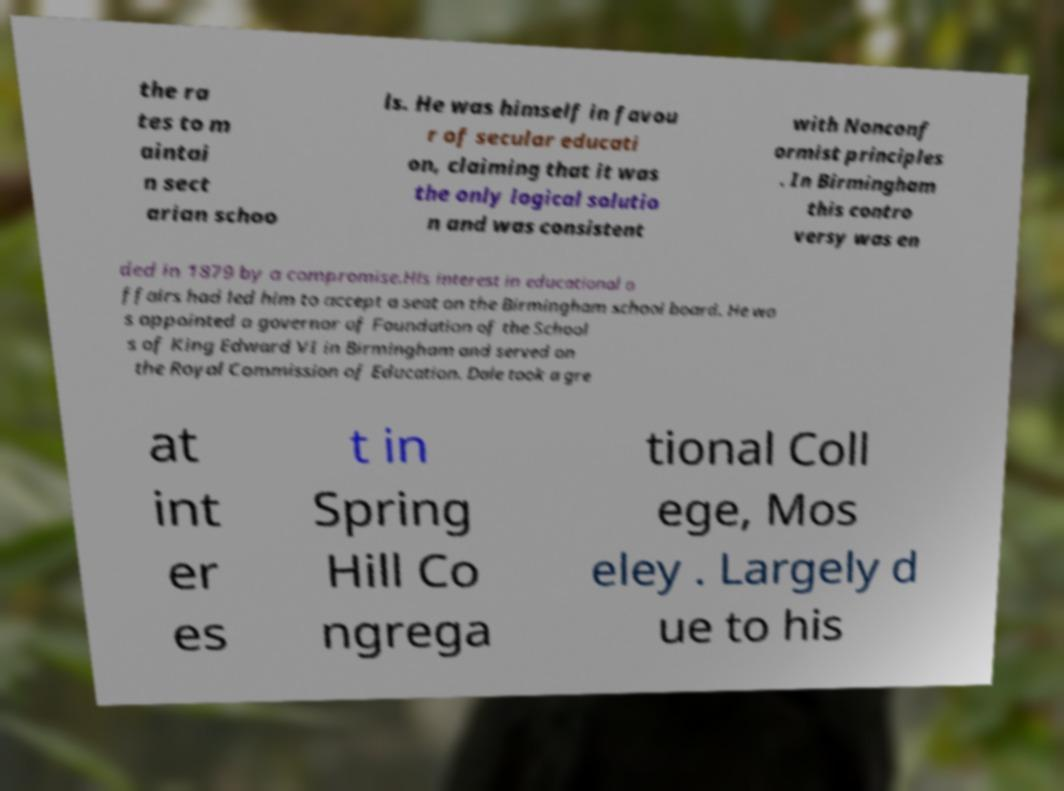Could you assist in decoding the text presented in this image and type it out clearly? the ra tes to m aintai n sect arian schoo ls. He was himself in favou r of secular educati on, claiming that it was the only logical solutio n and was consistent with Nonconf ormist principles . In Birmingham this contro versy was en ded in 1879 by a compromise.His interest in educational a ffairs had led him to accept a seat on the Birmingham school board. He wa s appointed a governor of Foundation of the School s of King Edward VI in Birmingham and served on the Royal Commission of Education. Dale took a gre at int er es t in Spring Hill Co ngrega tional Coll ege, Mos eley . Largely d ue to his 